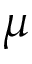Convert formula to latex. <formula><loc_0><loc_0><loc_500><loc_500>\mu</formula> 